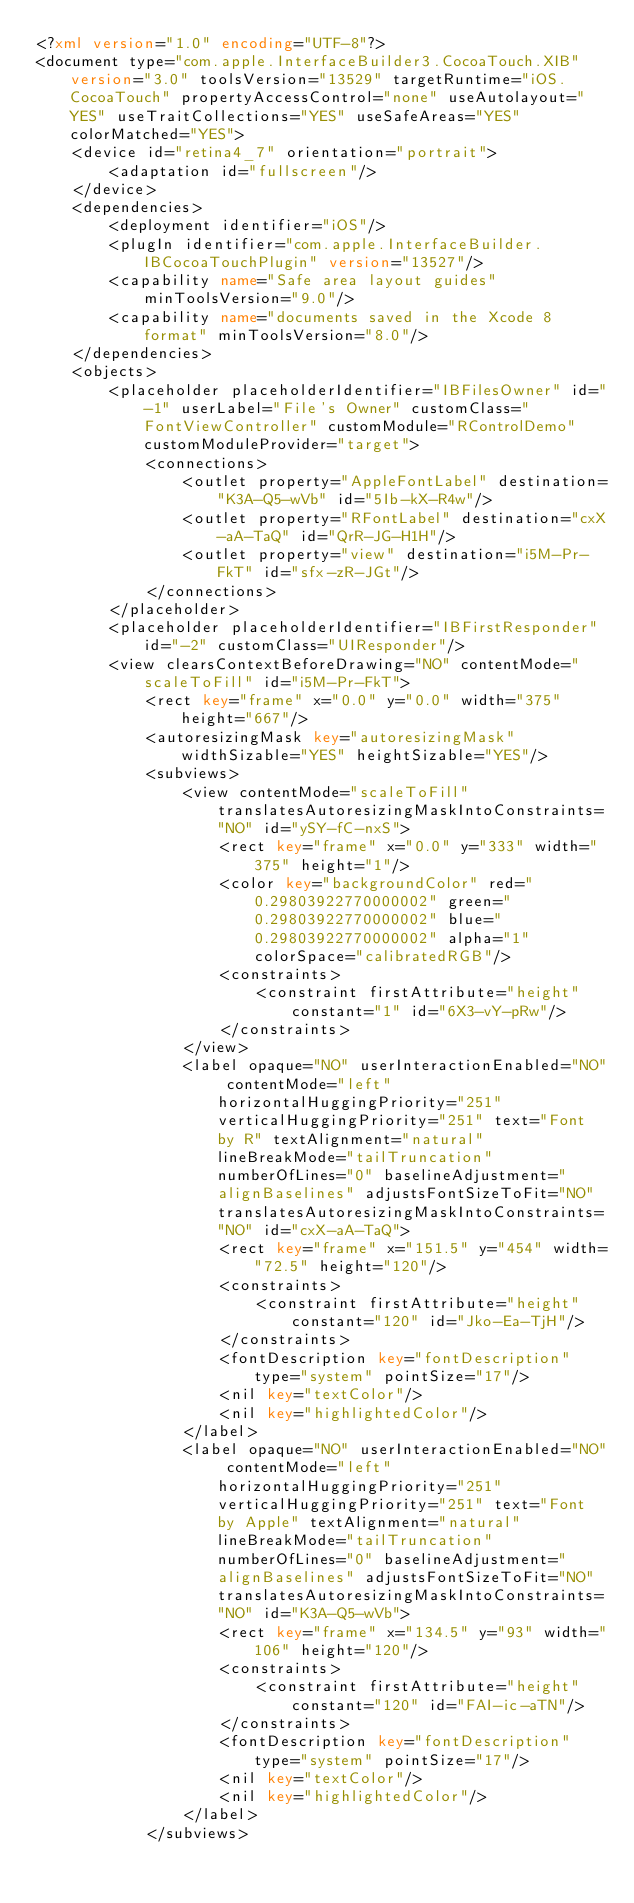Convert code to text. <code><loc_0><loc_0><loc_500><loc_500><_XML_><?xml version="1.0" encoding="UTF-8"?>
<document type="com.apple.InterfaceBuilder3.CocoaTouch.XIB" version="3.0" toolsVersion="13529" targetRuntime="iOS.CocoaTouch" propertyAccessControl="none" useAutolayout="YES" useTraitCollections="YES" useSafeAreas="YES" colorMatched="YES">
    <device id="retina4_7" orientation="portrait">
        <adaptation id="fullscreen"/>
    </device>
    <dependencies>
        <deployment identifier="iOS"/>
        <plugIn identifier="com.apple.InterfaceBuilder.IBCocoaTouchPlugin" version="13527"/>
        <capability name="Safe area layout guides" minToolsVersion="9.0"/>
        <capability name="documents saved in the Xcode 8 format" minToolsVersion="8.0"/>
    </dependencies>
    <objects>
        <placeholder placeholderIdentifier="IBFilesOwner" id="-1" userLabel="File's Owner" customClass="FontViewController" customModule="RControlDemo" customModuleProvider="target">
            <connections>
                <outlet property="AppleFontLabel" destination="K3A-Q5-wVb" id="5Ib-kX-R4w"/>
                <outlet property="RFontLabel" destination="cxX-aA-TaQ" id="QrR-JG-H1H"/>
                <outlet property="view" destination="i5M-Pr-FkT" id="sfx-zR-JGt"/>
            </connections>
        </placeholder>
        <placeholder placeholderIdentifier="IBFirstResponder" id="-2" customClass="UIResponder"/>
        <view clearsContextBeforeDrawing="NO" contentMode="scaleToFill" id="i5M-Pr-FkT">
            <rect key="frame" x="0.0" y="0.0" width="375" height="667"/>
            <autoresizingMask key="autoresizingMask" widthSizable="YES" heightSizable="YES"/>
            <subviews>
                <view contentMode="scaleToFill" translatesAutoresizingMaskIntoConstraints="NO" id="ySY-fC-nxS">
                    <rect key="frame" x="0.0" y="333" width="375" height="1"/>
                    <color key="backgroundColor" red="0.29803922770000002" green="0.29803922770000002" blue="0.29803922770000002" alpha="1" colorSpace="calibratedRGB"/>
                    <constraints>
                        <constraint firstAttribute="height" constant="1" id="6X3-vY-pRw"/>
                    </constraints>
                </view>
                <label opaque="NO" userInteractionEnabled="NO" contentMode="left" horizontalHuggingPriority="251" verticalHuggingPriority="251" text="Font by R" textAlignment="natural" lineBreakMode="tailTruncation" numberOfLines="0" baselineAdjustment="alignBaselines" adjustsFontSizeToFit="NO" translatesAutoresizingMaskIntoConstraints="NO" id="cxX-aA-TaQ">
                    <rect key="frame" x="151.5" y="454" width="72.5" height="120"/>
                    <constraints>
                        <constraint firstAttribute="height" constant="120" id="Jko-Ea-TjH"/>
                    </constraints>
                    <fontDescription key="fontDescription" type="system" pointSize="17"/>
                    <nil key="textColor"/>
                    <nil key="highlightedColor"/>
                </label>
                <label opaque="NO" userInteractionEnabled="NO" contentMode="left" horizontalHuggingPriority="251" verticalHuggingPriority="251" text="Font by Apple" textAlignment="natural" lineBreakMode="tailTruncation" numberOfLines="0" baselineAdjustment="alignBaselines" adjustsFontSizeToFit="NO" translatesAutoresizingMaskIntoConstraints="NO" id="K3A-Q5-wVb">
                    <rect key="frame" x="134.5" y="93" width="106" height="120"/>
                    <constraints>
                        <constraint firstAttribute="height" constant="120" id="FAI-ic-aTN"/>
                    </constraints>
                    <fontDescription key="fontDescription" type="system" pointSize="17"/>
                    <nil key="textColor"/>
                    <nil key="highlightedColor"/>
                </label>
            </subviews></code> 